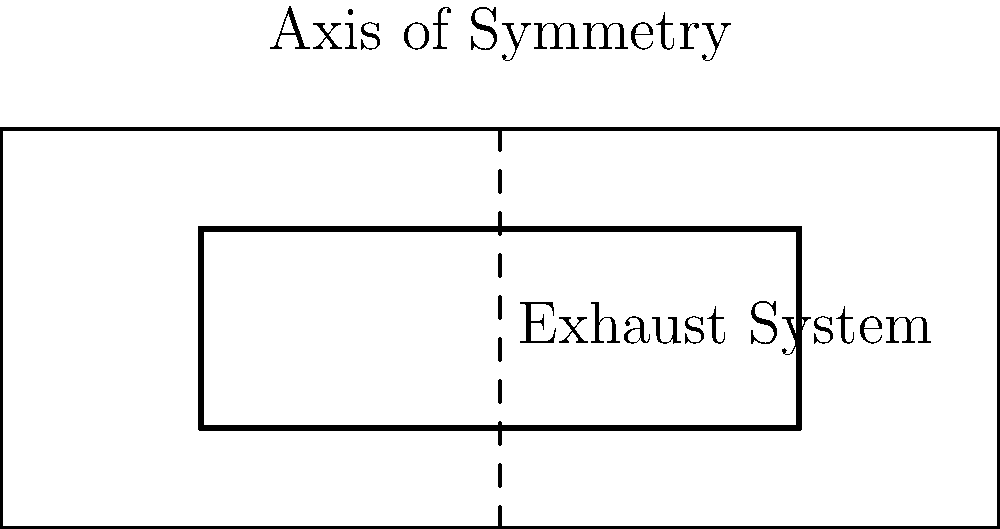In the top-view diagram of a Japanese superbike, the exhaust system layout is shown. Considering the axis of symmetry, which transformation would make the left exhaust system congruent to the right exhaust system? To determine the transformation that would make the left exhaust system congruent to the right exhaust system, we need to follow these steps:

1. Observe the position of both exhaust systems relative to the axis of symmetry.
2. The left exhaust system is below the axis of symmetry, while the right exhaust system is above it.
3. The distance of each exhaust system from the axis of symmetry appears to be equal.
4. The shape and size of both exhaust systems are identical.
5. To transform the left exhaust system to match the position of the right exhaust system, we need to reflect it across the axis of symmetry.
6. Reflection across a line maintains the shape and size of the object, resulting in congruence.
7. After reflection, the left exhaust system would perfectly align with the position of the right exhaust system.

Therefore, the transformation that would make the left exhaust system congruent to the right exhaust system is a reflection across the axis of symmetry.
Answer: Reflection across the axis of symmetry 